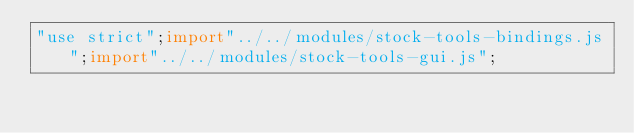Convert code to text. <code><loc_0><loc_0><loc_500><loc_500><_JavaScript_>"use strict";import"../../modules/stock-tools-bindings.js";import"../../modules/stock-tools-gui.js";</code> 